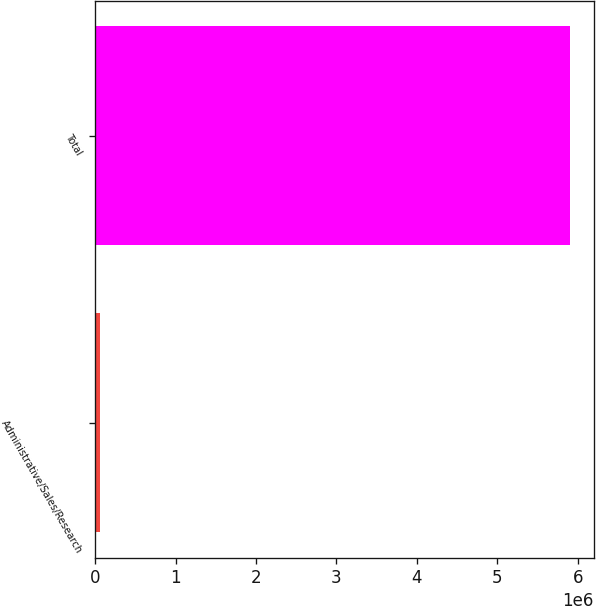Convert chart to OTSL. <chart><loc_0><loc_0><loc_500><loc_500><bar_chart><fcel>Administrative/Sales/Research<fcel>Total<nl><fcel>65000<fcel>5.905e+06<nl></chart> 